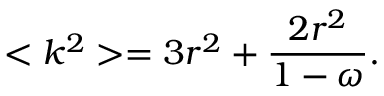Convert formula to latex. <formula><loc_0><loc_0><loc_500><loc_500>< k ^ { 2 } > = 3 r ^ { 2 } + \frac { 2 r ^ { 2 } } { 1 - \omega } .</formula> 